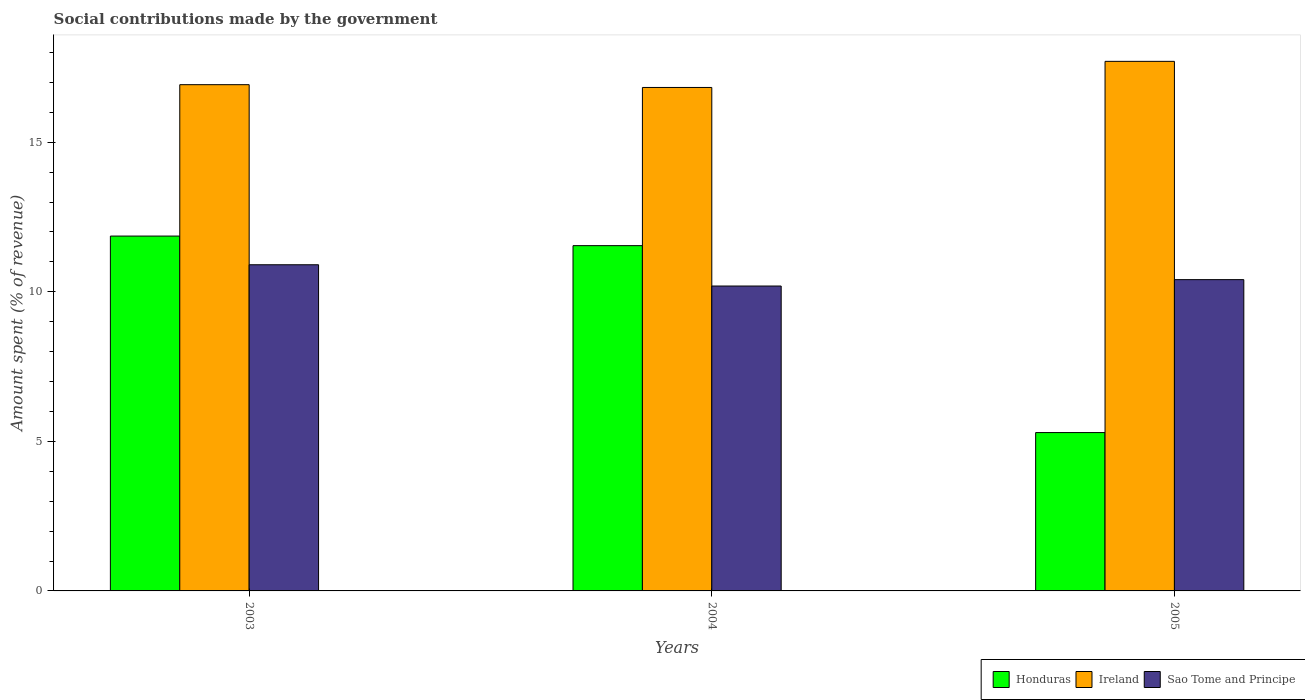How many different coloured bars are there?
Your answer should be compact. 3. How many bars are there on the 2nd tick from the left?
Your answer should be compact. 3. How many bars are there on the 3rd tick from the right?
Offer a terse response. 3. In how many cases, is the number of bars for a given year not equal to the number of legend labels?
Offer a terse response. 0. What is the amount spent (in %) on social contributions in Ireland in 2005?
Offer a very short reply. 17.7. Across all years, what is the maximum amount spent (in %) on social contributions in Honduras?
Ensure brevity in your answer.  11.86. Across all years, what is the minimum amount spent (in %) on social contributions in Sao Tome and Principe?
Make the answer very short. 10.19. In which year was the amount spent (in %) on social contributions in Ireland maximum?
Provide a short and direct response. 2005. What is the total amount spent (in %) on social contributions in Sao Tome and Principe in the graph?
Your answer should be compact. 31.5. What is the difference between the amount spent (in %) on social contributions in Ireland in 2003 and that in 2005?
Provide a succinct answer. -0.78. What is the difference between the amount spent (in %) on social contributions in Sao Tome and Principe in 2005 and the amount spent (in %) on social contributions in Honduras in 2004?
Your response must be concise. -1.14. What is the average amount spent (in %) on social contributions in Ireland per year?
Offer a very short reply. 17.15. In the year 2004, what is the difference between the amount spent (in %) on social contributions in Ireland and amount spent (in %) on social contributions in Honduras?
Provide a short and direct response. 5.29. What is the ratio of the amount spent (in %) on social contributions in Honduras in 2003 to that in 2005?
Ensure brevity in your answer.  2.24. Is the amount spent (in %) on social contributions in Ireland in 2004 less than that in 2005?
Your answer should be compact. Yes. What is the difference between the highest and the second highest amount spent (in %) on social contributions in Ireland?
Provide a short and direct response. 0.78. What is the difference between the highest and the lowest amount spent (in %) on social contributions in Sao Tome and Principe?
Provide a succinct answer. 0.71. In how many years, is the amount spent (in %) on social contributions in Honduras greater than the average amount spent (in %) on social contributions in Honduras taken over all years?
Your answer should be very brief. 2. Is the sum of the amount spent (in %) on social contributions in Ireland in 2003 and 2005 greater than the maximum amount spent (in %) on social contributions in Sao Tome and Principe across all years?
Provide a short and direct response. Yes. What does the 2nd bar from the left in 2005 represents?
Give a very brief answer. Ireland. What does the 2nd bar from the right in 2005 represents?
Give a very brief answer. Ireland. Is it the case that in every year, the sum of the amount spent (in %) on social contributions in Ireland and amount spent (in %) on social contributions in Sao Tome and Principe is greater than the amount spent (in %) on social contributions in Honduras?
Give a very brief answer. Yes. What is the difference between two consecutive major ticks on the Y-axis?
Ensure brevity in your answer.  5. Are the values on the major ticks of Y-axis written in scientific E-notation?
Your answer should be very brief. No. Does the graph contain grids?
Ensure brevity in your answer.  No. How are the legend labels stacked?
Give a very brief answer. Horizontal. What is the title of the graph?
Offer a very short reply. Social contributions made by the government. Does "World" appear as one of the legend labels in the graph?
Your response must be concise. No. What is the label or title of the Y-axis?
Your answer should be very brief. Amount spent (% of revenue). What is the Amount spent (% of revenue) of Honduras in 2003?
Give a very brief answer. 11.86. What is the Amount spent (% of revenue) of Ireland in 2003?
Provide a short and direct response. 16.92. What is the Amount spent (% of revenue) in Sao Tome and Principe in 2003?
Give a very brief answer. 10.9. What is the Amount spent (% of revenue) in Honduras in 2004?
Give a very brief answer. 11.54. What is the Amount spent (% of revenue) in Ireland in 2004?
Provide a short and direct response. 16.83. What is the Amount spent (% of revenue) of Sao Tome and Principe in 2004?
Your answer should be very brief. 10.19. What is the Amount spent (% of revenue) of Honduras in 2005?
Provide a succinct answer. 5.29. What is the Amount spent (% of revenue) of Ireland in 2005?
Offer a terse response. 17.7. What is the Amount spent (% of revenue) of Sao Tome and Principe in 2005?
Keep it short and to the point. 10.41. Across all years, what is the maximum Amount spent (% of revenue) of Honduras?
Provide a short and direct response. 11.86. Across all years, what is the maximum Amount spent (% of revenue) in Ireland?
Provide a succinct answer. 17.7. Across all years, what is the maximum Amount spent (% of revenue) of Sao Tome and Principe?
Give a very brief answer. 10.9. Across all years, what is the minimum Amount spent (% of revenue) in Honduras?
Ensure brevity in your answer.  5.29. Across all years, what is the minimum Amount spent (% of revenue) in Ireland?
Your response must be concise. 16.83. Across all years, what is the minimum Amount spent (% of revenue) in Sao Tome and Principe?
Provide a succinct answer. 10.19. What is the total Amount spent (% of revenue) in Honduras in the graph?
Ensure brevity in your answer.  28.7. What is the total Amount spent (% of revenue) in Ireland in the graph?
Your answer should be compact. 51.46. What is the total Amount spent (% of revenue) in Sao Tome and Principe in the graph?
Your answer should be very brief. 31.5. What is the difference between the Amount spent (% of revenue) of Honduras in 2003 and that in 2004?
Provide a short and direct response. 0.32. What is the difference between the Amount spent (% of revenue) in Ireland in 2003 and that in 2004?
Provide a short and direct response. 0.09. What is the difference between the Amount spent (% of revenue) of Sao Tome and Principe in 2003 and that in 2004?
Offer a terse response. 0.71. What is the difference between the Amount spent (% of revenue) of Honduras in 2003 and that in 2005?
Offer a very short reply. 6.57. What is the difference between the Amount spent (% of revenue) of Ireland in 2003 and that in 2005?
Your answer should be compact. -0.78. What is the difference between the Amount spent (% of revenue) of Sao Tome and Principe in 2003 and that in 2005?
Offer a terse response. 0.5. What is the difference between the Amount spent (% of revenue) of Honduras in 2004 and that in 2005?
Your response must be concise. 6.25. What is the difference between the Amount spent (% of revenue) in Ireland in 2004 and that in 2005?
Keep it short and to the point. -0.87. What is the difference between the Amount spent (% of revenue) of Sao Tome and Principe in 2004 and that in 2005?
Give a very brief answer. -0.21. What is the difference between the Amount spent (% of revenue) in Honduras in 2003 and the Amount spent (% of revenue) in Ireland in 2004?
Your answer should be compact. -4.97. What is the difference between the Amount spent (% of revenue) of Honduras in 2003 and the Amount spent (% of revenue) of Sao Tome and Principe in 2004?
Provide a short and direct response. 1.67. What is the difference between the Amount spent (% of revenue) in Ireland in 2003 and the Amount spent (% of revenue) in Sao Tome and Principe in 2004?
Offer a terse response. 6.73. What is the difference between the Amount spent (% of revenue) of Honduras in 2003 and the Amount spent (% of revenue) of Ireland in 2005?
Keep it short and to the point. -5.84. What is the difference between the Amount spent (% of revenue) of Honduras in 2003 and the Amount spent (% of revenue) of Sao Tome and Principe in 2005?
Offer a very short reply. 1.46. What is the difference between the Amount spent (% of revenue) in Ireland in 2003 and the Amount spent (% of revenue) in Sao Tome and Principe in 2005?
Provide a succinct answer. 6.52. What is the difference between the Amount spent (% of revenue) in Honduras in 2004 and the Amount spent (% of revenue) in Ireland in 2005?
Ensure brevity in your answer.  -6.16. What is the difference between the Amount spent (% of revenue) in Honduras in 2004 and the Amount spent (% of revenue) in Sao Tome and Principe in 2005?
Ensure brevity in your answer.  1.14. What is the difference between the Amount spent (% of revenue) of Ireland in 2004 and the Amount spent (% of revenue) of Sao Tome and Principe in 2005?
Your response must be concise. 6.42. What is the average Amount spent (% of revenue) of Honduras per year?
Provide a succinct answer. 9.57. What is the average Amount spent (% of revenue) of Ireland per year?
Ensure brevity in your answer.  17.15. What is the average Amount spent (% of revenue) in Sao Tome and Principe per year?
Your answer should be very brief. 10.5. In the year 2003, what is the difference between the Amount spent (% of revenue) in Honduras and Amount spent (% of revenue) in Ireland?
Provide a succinct answer. -5.06. In the year 2003, what is the difference between the Amount spent (% of revenue) of Honduras and Amount spent (% of revenue) of Sao Tome and Principe?
Your answer should be very brief. 0.96. In the year 2003, what is the difference between the Amount spent (% of revenue) of Ireland and Amount spent (% of revenue) of Sao Tome and Principe?
Provide a succinct answer. 6.02. In the year 2004, what is the difference between the Amount spent (% of revenue) in Honduras and Amount spent (% of revenue) in Ireland?
Your answer should be very brief. -5.29. In the year 2004, what is the difference between the Amount spent (% of revenue) of Honduras and Amount spent (% of revenue) of Sao Tome and Principe?
Make the answer very short. 1.35. In the year 2004, what is the difference between the Amount spent (% of revenue) in Ireland and Amount spent (% of revenue) in Sao Tome and Principe?
Provide a short and direct response. 6.64. In the year 2005, what is the difference between the Amount spent (% of revenue) in Honduras and Amount spent (% of revenue) in Ireland?
Provide a succinct answer. -12.41. In the year 2005, what is the difference between the Amount spent (% of revenue) of Honduras and Amount spent (% of revenue) of Sao Tome and Principe?
Your answer should be compact. -5.11. In the year 2005, what is the difference between the Amount spent (% of revenue) in Ireland and Amount spent (% of revenue) in Sao Tome and Principe?
Offer a very short reply. 7.3. What is the ratio of the Amount spent (% of revenue) of Honduras in 2003 to that in 2004?
Provide a short and direct response. 1.03. What is the ratio of the Amount spent (% of revenue) in Sao Tome and Principe in 2003 to that in 2004?
Your answer should be compact. 1.07. What is the ratio of the Amount spent (% of revenue) in Honduras in 2003 to that in 2005?
Your response must be concise. 2.24. What is the ratio of the Amount spent (% of revenue) in Ireland in 2003 to that in 2005?
Provide a short and direct response. 0.96. What is the ratio of the Amount spent (% of revenue) of Sao Tome and Principe in 2003 to that in 2005?
Ensure brevity in your answer.  1.05. What is the ratio of the Amount spent (% of revenue) of Honduras in 2004 to that in 2005?
Ensure brevity in your answer.  2.18. What is the ratio of the Amount spent (% of revenue) in Ireland in 2004 to that in 2005?
Offer a terse response. 0.95. What is the ratio of the Amount spent (% of revenue) in Sao Tome and Principe in 2004 to that in 2005?
Give a very brief answer. 0.98. What is the difference between the highest and the second highest Amount spent (% of revenue) of Honduras?
Ensure brevity in your answer.  0.32. What is the difference between the highest and the second highest Amount spent (% of revenue) in Ireland?
Give a very brief answer. 0.78. What is the difference between the highest and the second highest Amount spent (% of revenue) of Sao Tome and Principe?
Give a very brief answer. 0.5. What is the difference between the highest and the lowest Amount spent (% of revenue) in Honduras?
Your answer should be very brief. 6.57. What is the difference between the highest and the lowest Amount spent (% of revenue) of Ireland?
Make the answer very short. 0.87. What is the difference between the highest and the lowest Amount spent (% of revenue) of Sao Tome and Principe?
Offer a very short reply. 0.71. 